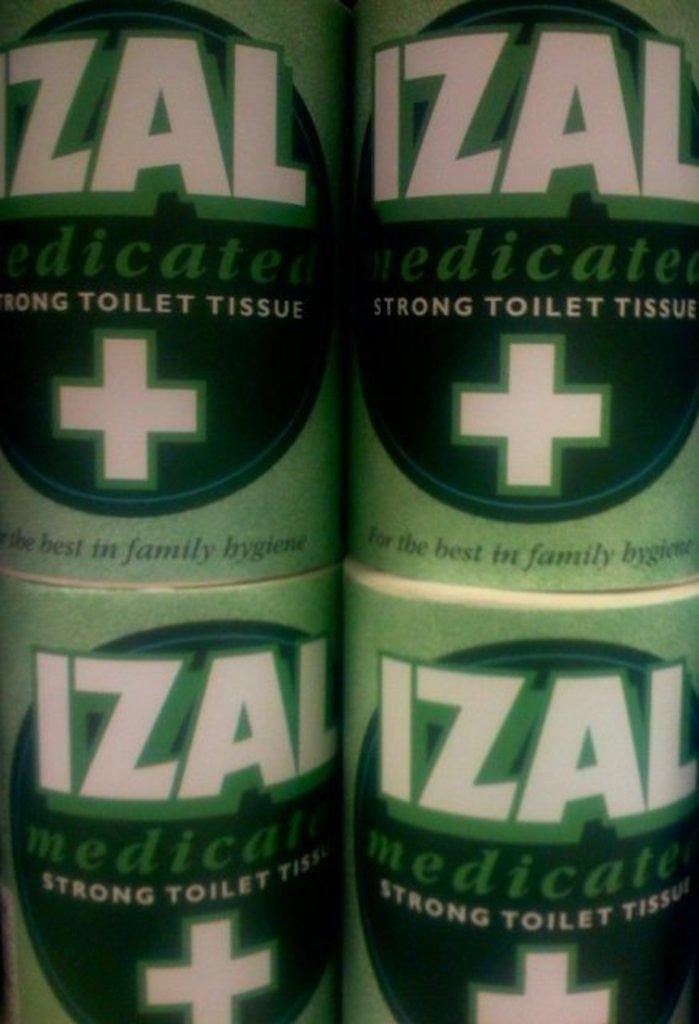<image>
Give a short and clear explanation of the subsequent image. The brand of toilet tissue that is stacked up is Izal. 